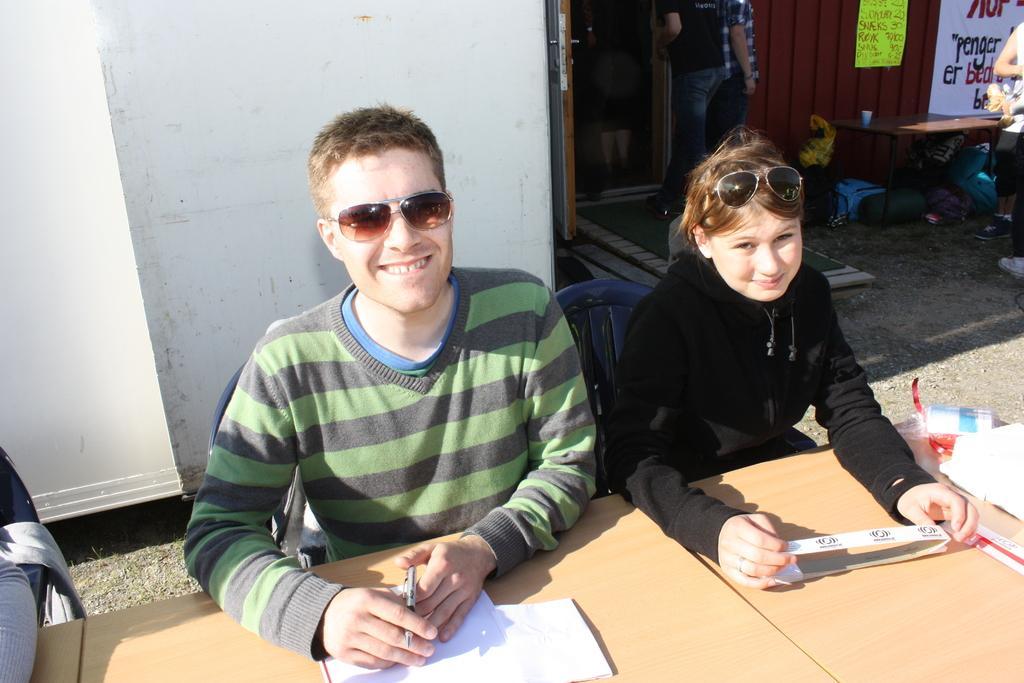Can you describe this image briefly? In this picture there are two person sitting in chairs in front of a table. A man is wearing a goggles and striped sweater is holding a pen. Besides him there is a woman wearing a goggles and a black jacket. Towards the left there is an another person. In the background there is a vehicle, door, two persons , a table. Towards the right there is another person. 